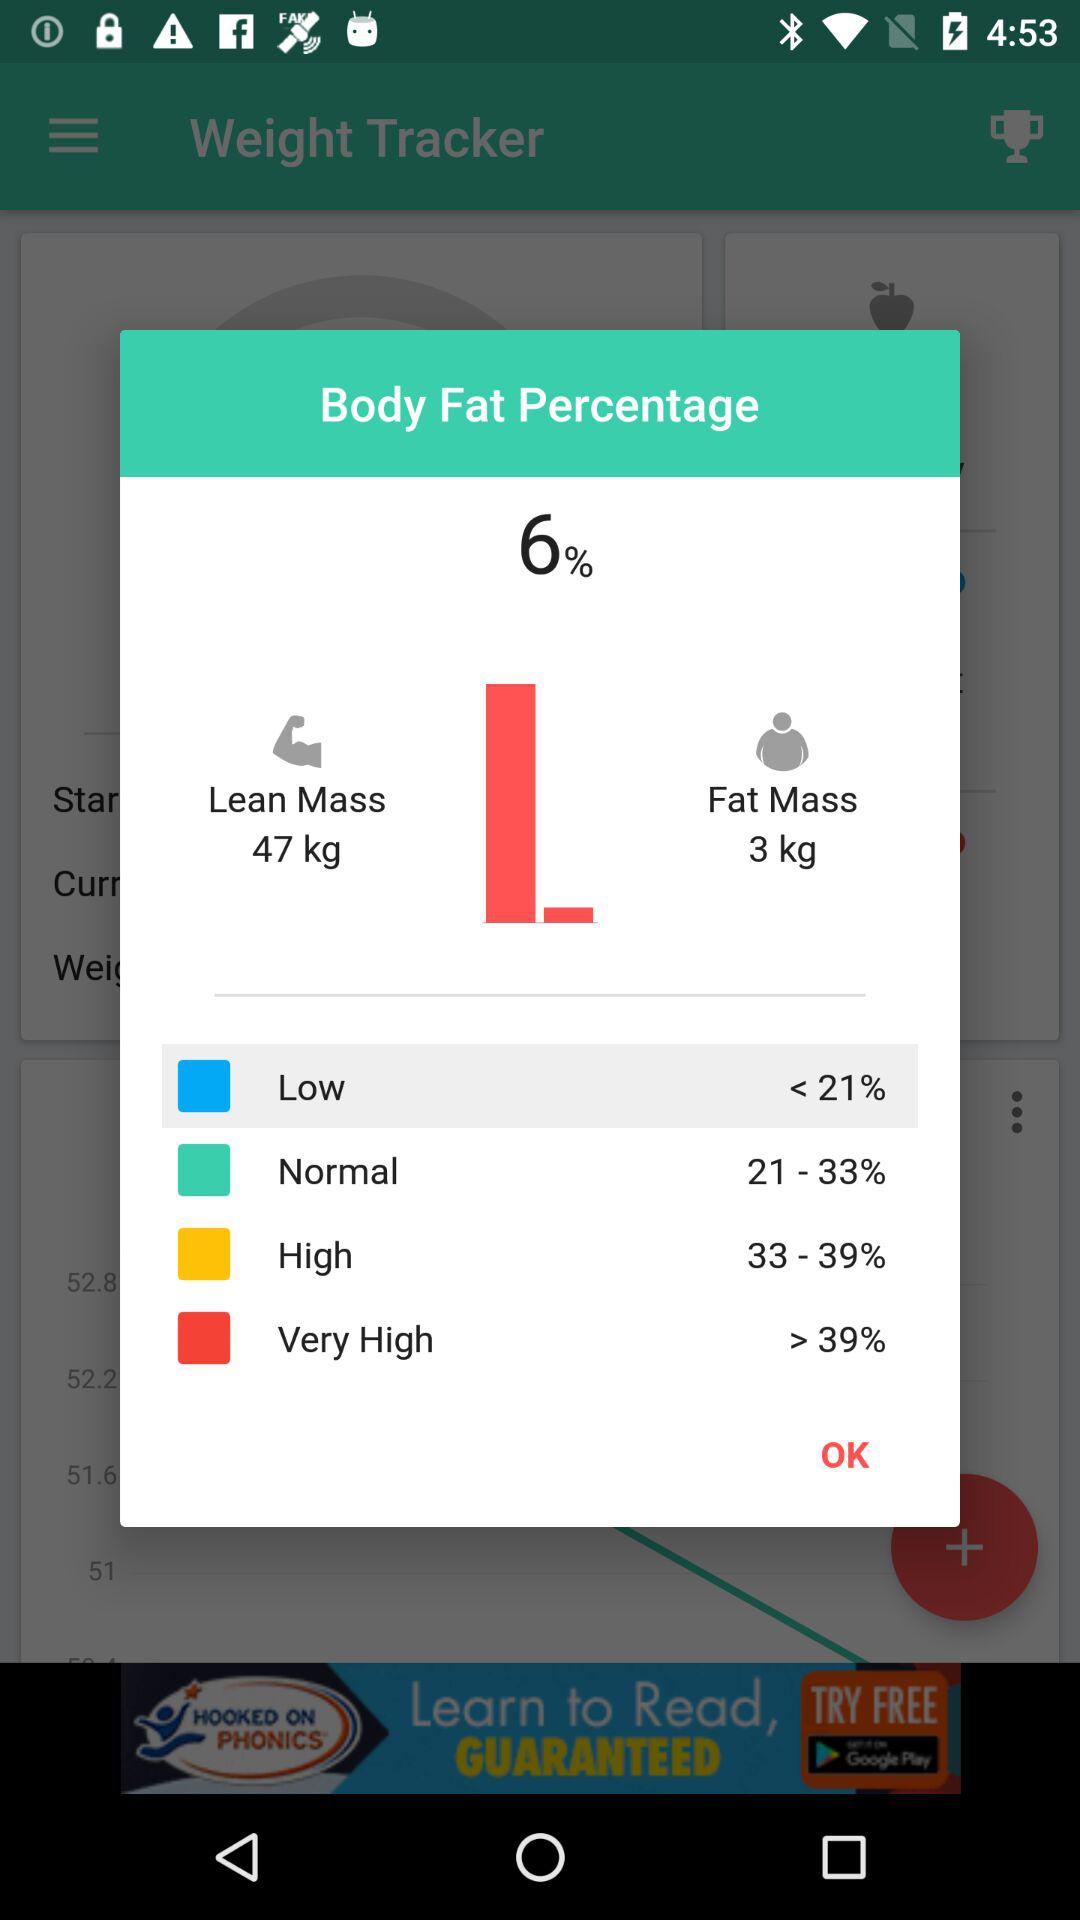What is the quantity of lean mass? The quantity of lean mass is 47 kg. 